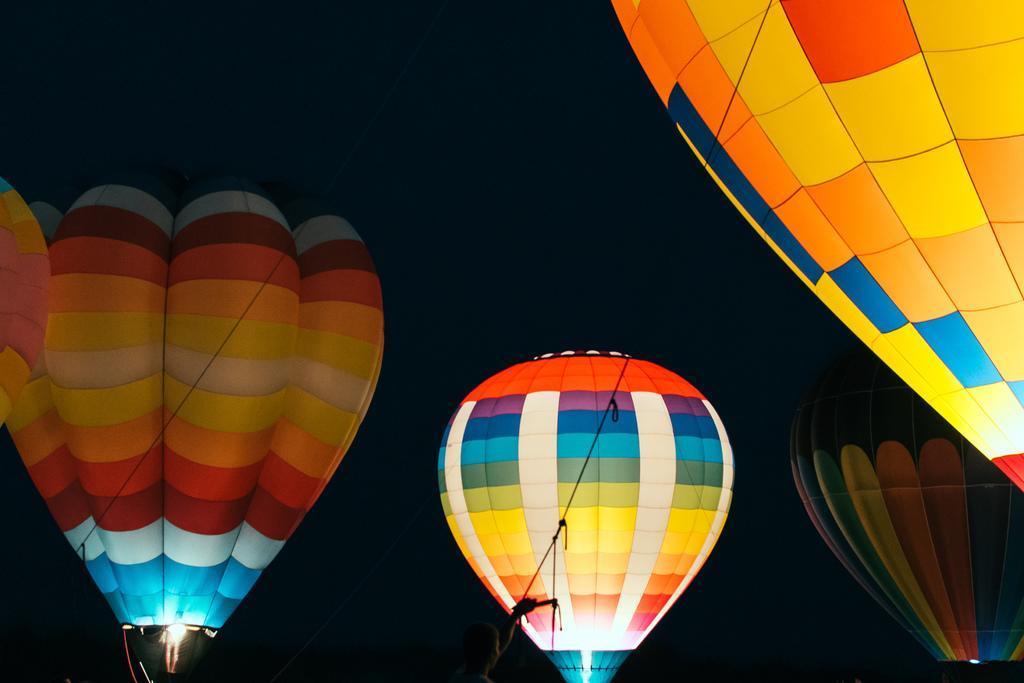Please provide a concise description of this image. In this image I see 4 hot air balloons which are of different in colors and I see the rope over here and I see the light and it is dark in the background. 